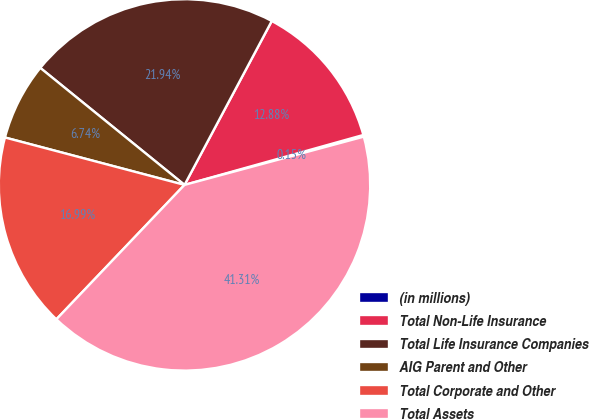Convert chart. <chart><loc_0><loc_0><loc_500><loc_500><pie_chart><fcel>(in millions)<fcel>Total Non-Life Insurance<fcel>Total Life Insurance Companies<fcel>AIG Parent and Other<fcel>Total Corporate and Other<fcel>Total Assets<nl><fcel>0.15%<fcel>12.88%<fcel>21.94%<fcel>6.74%<fcel>16.99%<fcel>41.31%<nl></chart> 